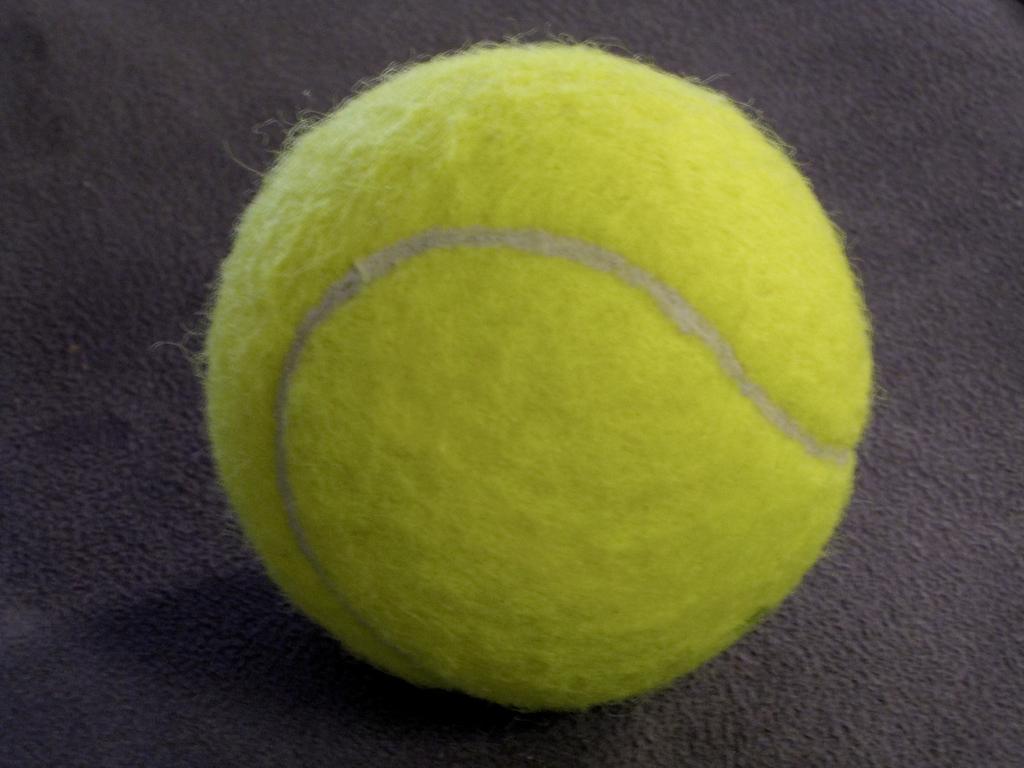Can you describe this image briefly? In this image we can see a ball on the carpet. 